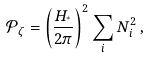<formula> <loc_0><loc_0><loc_500><loc_500>\mathcal { P } _ { \zeta } = \left ( \frac { H _ { ^ { * } } } { 2 \pi } \right ) ^ { 2 } \sum _ { i } N _ { i } ^ { 2 } \, ,</formula> 